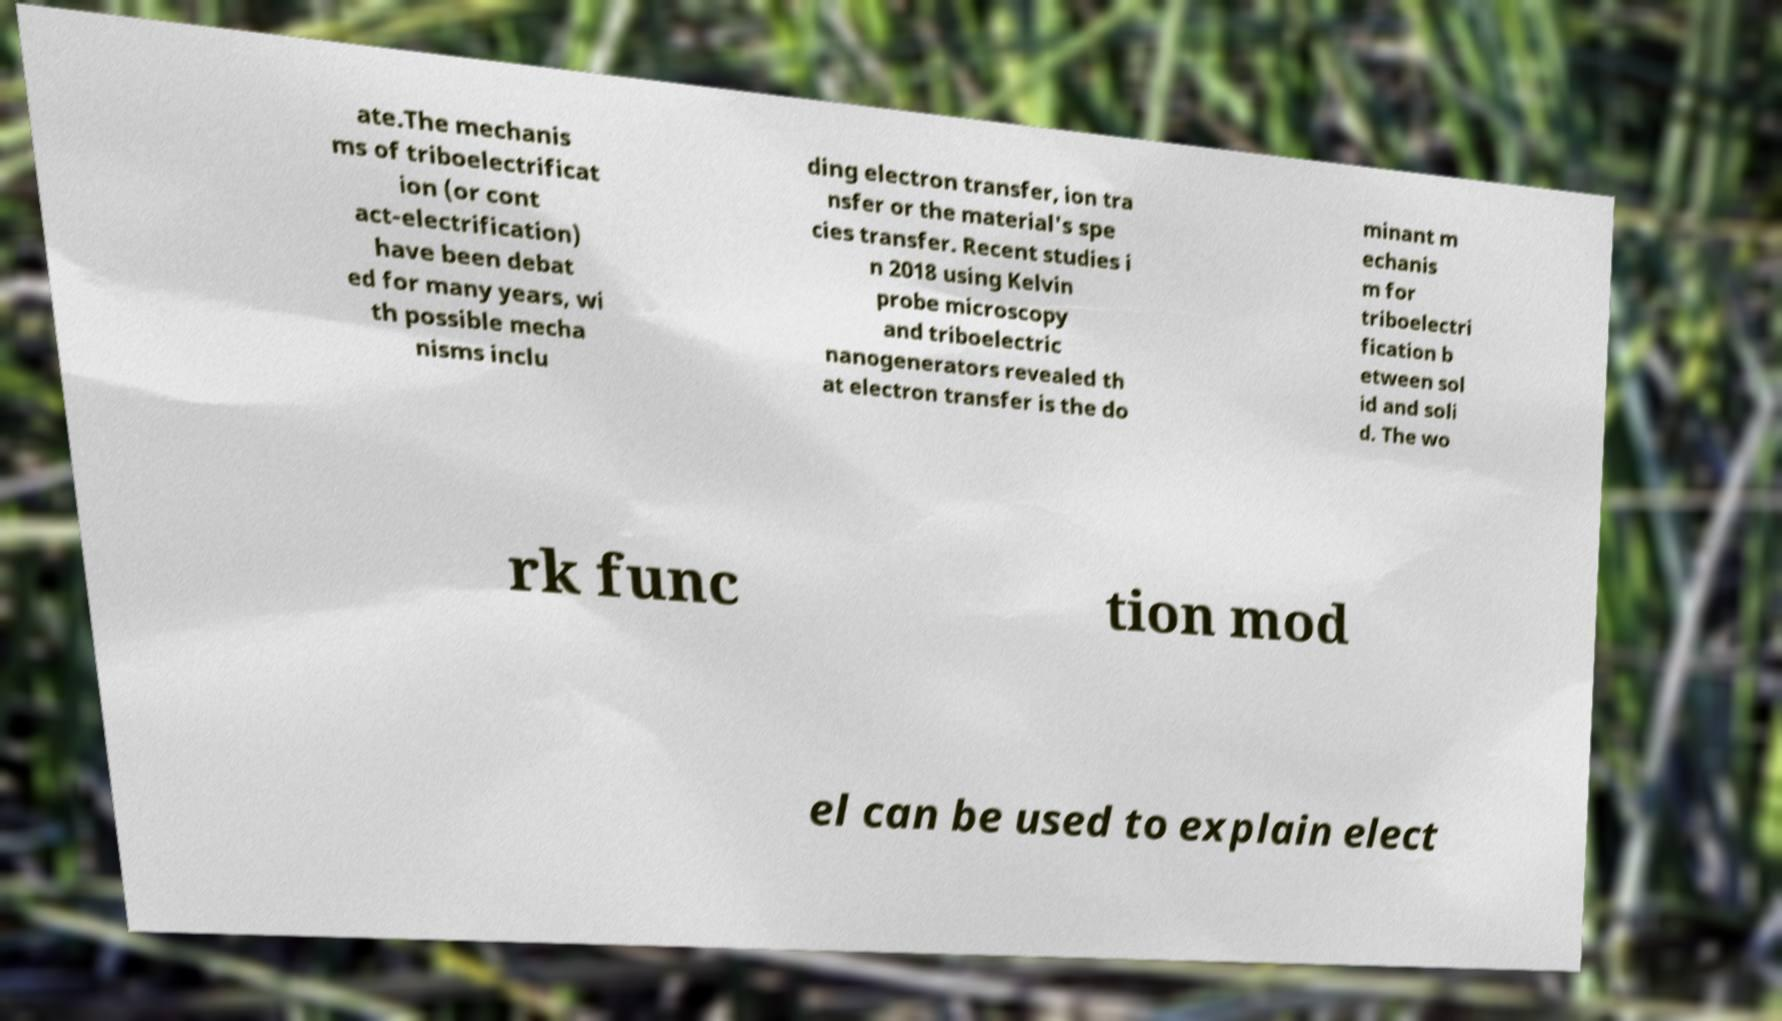For documentation purposes, I need the text within this image transcribed. Could you provide that? ate.The mechanis ms of triboelectrificat ion (or cont act-electrification) have been debat ed for many years, wi th possible mecha nisms inclu ding electron transfer, ion tra nsfer or the material's spe cies transfer. Recent studies i n 2018 using Kelvin probe microscopy and triboelectric nanogenerators revealed th at electron transfer is the do minant m echanis m for triboelectri fication b etween sol id and soli d. The wo rk func tion mod el can be used to explain elect 